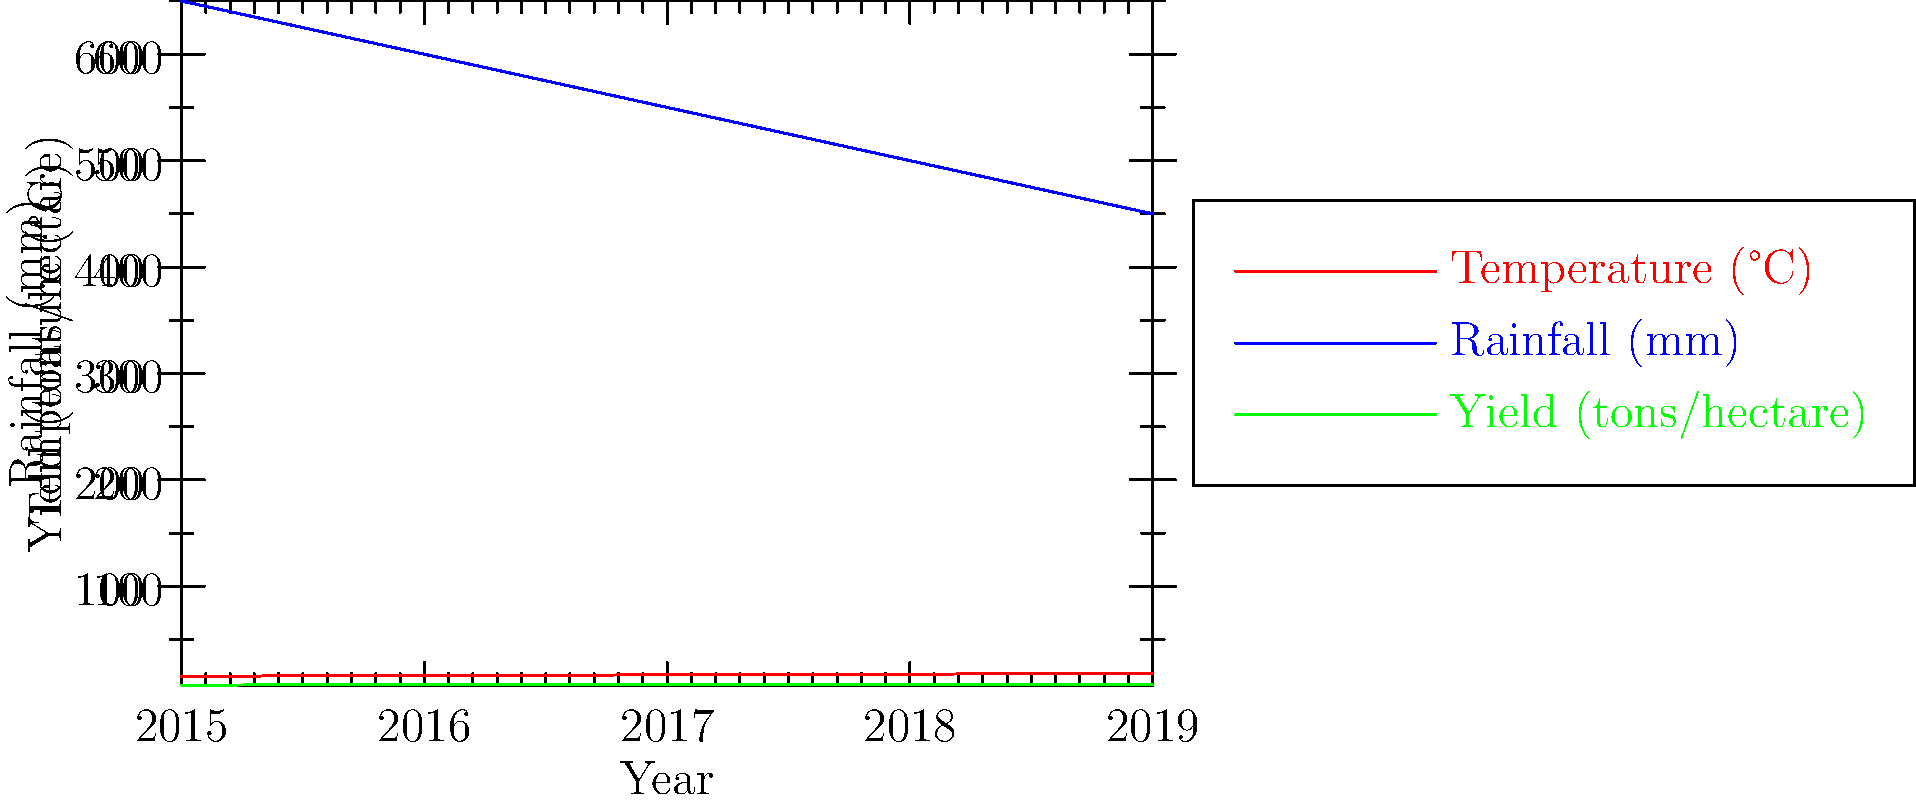Based on the multi-axis chart showing temperature, rainfall, and wine grape yield trends from 2015 to 2019, which climate factor appears to have the strongest correlation with yield, and how might this impact future wine production strategies? To answer this question, we need to analyze the relationships between the three variables over time:

1. Temperature trend:
   - Steadily increasing from 15.5°C in 2015 to 18.1°C in 2019

2. Rainfall trend:
   - Consistently decreasing from 650mm in 2015 to 450mm in 2019

3. Yield trend:
   - Increases from 7.2 tons/hectare in 2015 to 7.8 tons/hectare in 2017
   - Decreases from 7.8 tons/hectare in 2017 to 7.3 tons/hectare in 2019

4. Analyzing correlations:
   - Temperature shows a positive correlation with yield until 2017, then a negative correlation
   - Rainfall shows a negative correlation with yield until 2017, then a positive correlation

5. Strongest correlation:
   - Rainfall appears to have the strongest correlation with yield
   - As rainfall decreases, yield initially increases, but then decreases when rainfall drops below a certain threshold

6. Impact on future wine production strategies:
   - Producers may need to implement irrigation systems to compensate for decreasing rainfall
   - They might consider drought-resistant grape varieties
   - Water management techniques will become crucial for maintaining optimal yield

The relationship between rainfall and yield suggests an optimal range for grape production. Too much water may reduce yield, but too little water also negatively impacts yield. This indicates that careful water management will be key to future wine production strategies.
Answer: Rainfall; implement irrigation and water management techniques 